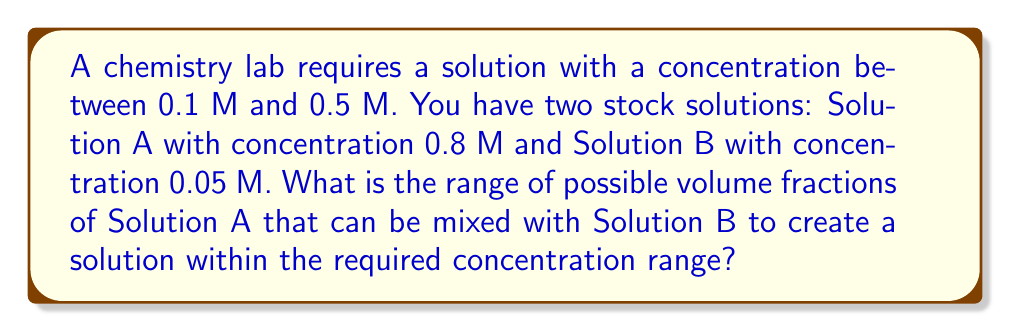What is the answer to this math problem? Let's approach this step-by-step:

1) Let $x$ be the volume fraction of Solution A. Then, $(1-x)$ is the volume fraction of Solution B.

2) The concentration of the mixed solution will be:

   $C = 0.8x + 0.05(1-x)$

3) We want this concentration to be between 0.1 M and 0.5 M:

   $0.1 \leq 0.8x + 0.05(1-x) \leq 0.5$

4) Simplify the inequality:

   $0.1 \leq 0.8x + 0.05 - 0.05x \leq 0.5$
   $0.1 \leq 0.75x + 0.05 \leq 0.5$

5) Subtract 0.05 from all parts:

   $0.05 \leq 0.75x \leq 0.45$

6) Divide all parts by 0.75:

   $\frac{1}{15} \leq x \leq \frac{3}{5}$

7) Convert to decimals:

   $0.0667 \leq x \leq 0.6$

Therefore, the volume fraction of Solution A should be between 0.0667 and 0.6.
Answer: $[0.0667, 0.6]$ 